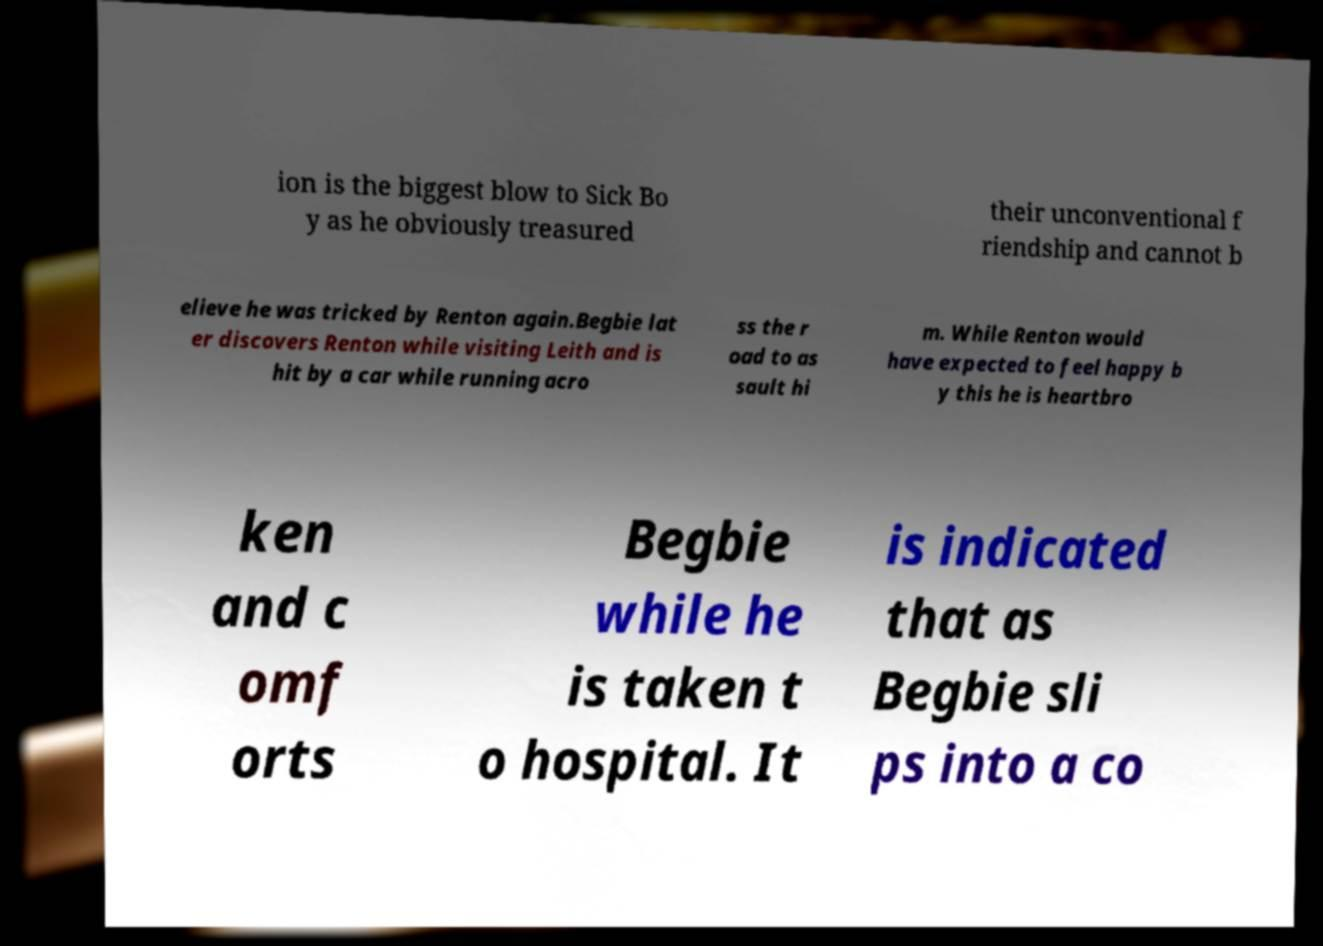Could you assist in decoding the text presented in this image and type it out clearly? ion is the biggest blow to Sick Bo y as he obviously treasured their unconventional f riendship and cannot b elieve he was tricked by Renton again.Begbie lat er discovers Renton while visiting Leith and is hit by a car while running acro ss the r oad to as sault hi m. While Renton would have expected to feel happy b y this he is heartbro ken and c omf orts Begbie while he is taken t o hospital. It is indicated that as Begbie sli ps into a co 